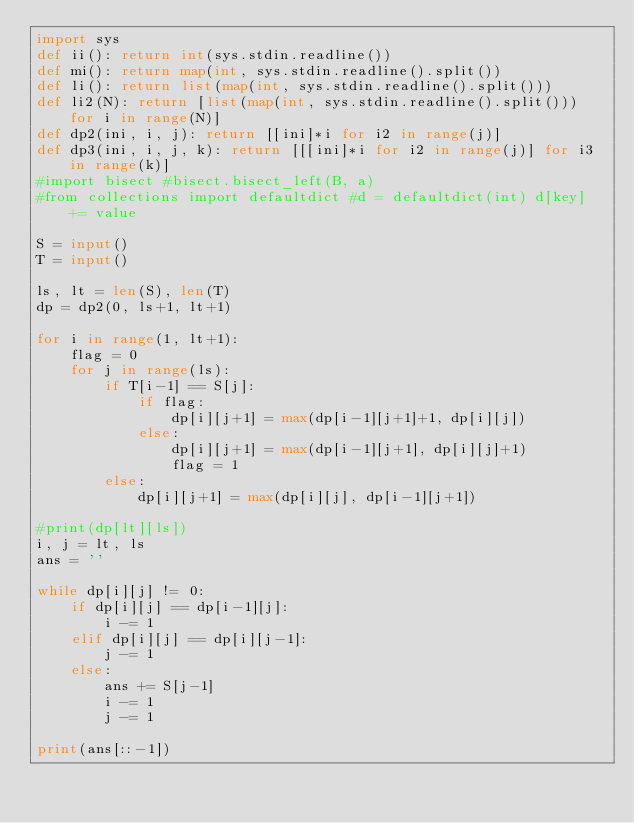Convert code to text. <code><loc_0><loc_0><loc_500><loc_500><_Python_>import sys
def ii(): return int(sys.stdin.readline())
def mi(): return map(int, sys.stdin.readline().split())
def li(): return list(map(int, sys.stdin.readline().split()))
def li2(N): return [list(map(int, sys.stdin.readline().split())) for i in range(N)]
def dp2(ini, i, j): return [[ini]*i for i2 in range(j)]
def dp3(ini, i, j, k): return [[[ini]*i for i2 in range(j)] for i3 in range(k)]
#import bisect #bisect.bisect_left(B, a)
#from collections import defaultdict #d = defaultdict(int) d[key] += value

S = input()
T = input()

ls, lt = len(S), len(T)
dp = dp2(0, ls+1, lt+1)

for i in range(1, lt+1):
    flag = 0
    for j in range(ls):
        if T[i-1] == S[j]:
            if flag:
                dp[i][j+1] = max(dp[i-1][j+1]+1, dp[i][j])
            else:
                dp[i][j+1] = max(dp[i-1][j+1], dp[i][j]+1)
                flag = 1
        else:
            dp[i][j+1] = max(dp[i][j], dp[i-1][j+1])

#print(dp[lt][ls])
i, j = lt, ls
ans = ''

while dp[i][j] != 0:
    if dp[i][j] == dp[i-1][j]:
        i -= 1
    elif dp[i][j] == dp[i][j-1]:
        j -= 1
    else:
        ans += S[j-1]
        i -= 1
        j -= 1

print(ans[::-1])</code> 